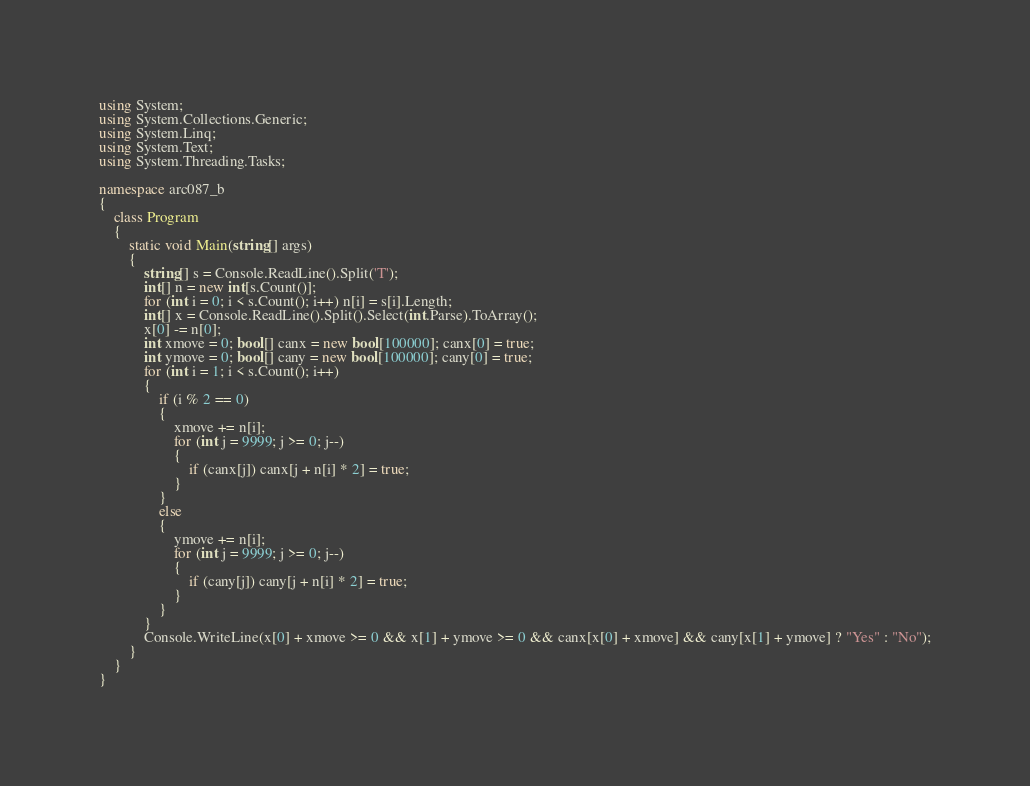Convert code to text. <code><loc_0><loc_0><loc_500><loc_500><_C#_>using System;
using System.Collections.Generic;
using System.Linq;
using System.Text;
using System.Threading.Tasks;

namespace arc087_b
{
    class Program
    {
        static void Main(string[] args)
        {
            string[] s = Console.ReadLine().Split('T');
            int[] n = new int[s.Count()];
            for (int i = 0; i < s.Count(); i++) n[i] = s[i].Length;
            int[] x = Console.ReadLine().Split().Select(int.Parse).ToArray();
            x[0] -= n[0];
            int xmove = 0; bool[] canx = new bool[100000]; canx[0] = true;
            int ymove = 0; bool[] cany = new bool[100000]; cany[0] = true;
            for (int i = 1; i < s.Count(); i++)
            {
                if (i % 2 == 0)
                {
                    xmove += n[i];
                    for (int j = 9999; j >= 0; j--)
                    {
                        if (canx[j]) canx[j + n[i] * 2] = true;
                    }
                }
                else
                {
                    ymove += n[i];
                    for (int j = 9999; j >= 0; j--)
                    {
                        if (cany[j]) cany[j + n[i] * 2] = true;
                    }
                }
            }
            Console.WriteLine(x[0] + xmove >= 0 && x[1] + ymove >= 0 && canx[x[0] + xmove] && cany[x[1] + ymove] ? "Yes" : "No");
        }
    }
}</code> 